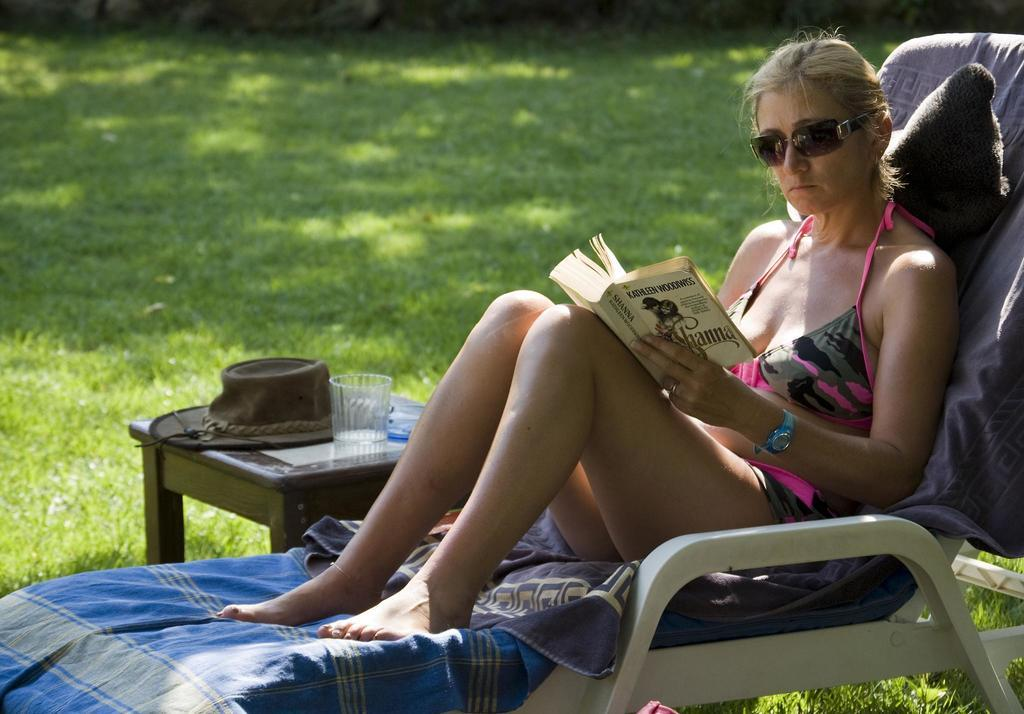What is the woman in the image doing? The woman is sitting on a chair and holding a book with her hands. What is the woman wearing on her face? The woman is wearing goggles. What objects can be seen on the table in the image? There is a hat and a glass on the table in the image. What type of surface is visible in the image? There is grass in the image. Can you tell me how many bananas are being offered to the goldfish in the image? There are no bananas or goldfish present in the image. 